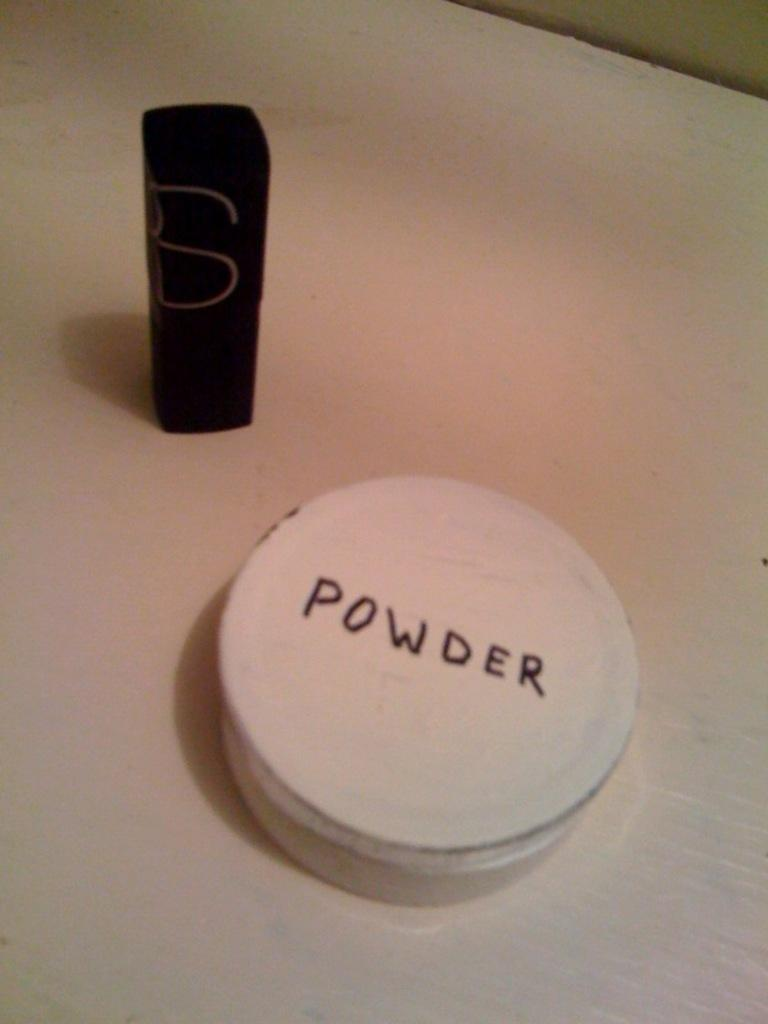<image>
Write a terse but informative summary of the picture. A round white container that is labeled Powder. 